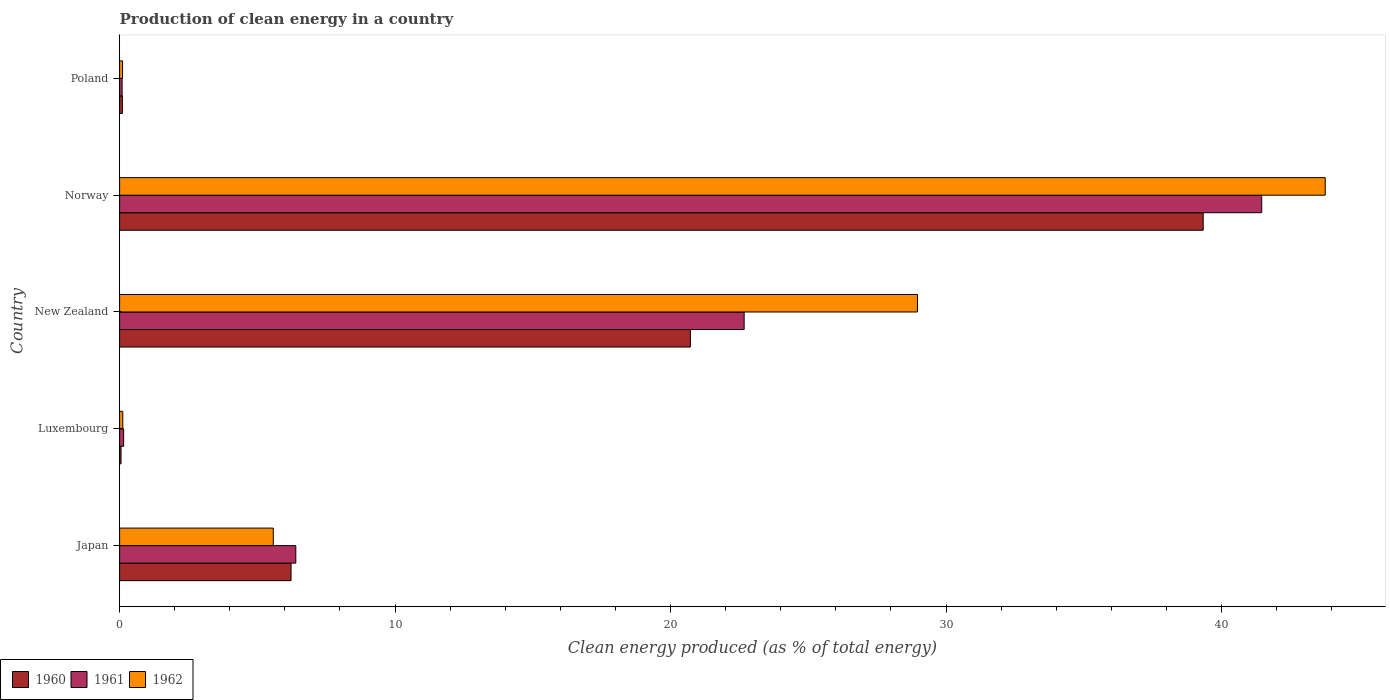How many groups of bars are there?
Provide a short and direct response. 5. How many bars are there on the 1st tick from the bottom?
Ensure brevity in your answer.  3. What is the label of the 5th group of bars from the top?
Your answer should be compact. Japan. In how many cases, is the number of bars for a given country not equal to the number of legend labels?
Ensure brevity in your answer.  0. What is the percentage of clean energy produced in 1962 in Luxembourg?
Offer a terse response. 0.12. Across all countries, what is the maximum percentage of clean energy produced in 1960?
Provide a short and direct response. 39.34. Across all countries, what is the minimum percentage of clean energy produced in 1962?
Your response must be concise. 0.11. In which country was the percentage of clean energy produced in 1962 minimum?
Provide a short and direct response. Poland. What is the total percentage of clean energy produced in 1962 in the graph?
Your response must be concise. 78.53. What is the difference between the percentage of clean energy produced in 1960 in Luxembourg and that in Norway?
Keep it short and to the point. -39.28. What is the difference between the percentage of clean energy produced in 1960 in Poland and the percentage of clean energy produced in 1961 in Luxembourg?
Your answer should be very brief. -0.05. What is the average percentage of clean energy produced in 1960 per country?
Your answer should be compact. 13.29. What is the difference between the percentage of clean energy produced in 1962 and percentage of clean energy produced in 1961 in Poland?
Provide a short and direct response. 0.02. What is the ratio of the percentage of clean energy produced in 1960 in Japan to that in New Zealand?
Offer a very short reply. 0.3. Is the percentage of clean energy produced in 1961 in Japan less than that in Poland?
Offer a terse response. No. What is the difference between the highest and the second highest percentage of clean energy produced in 1962?
Provide a short and direct response. 14.8. What is the difference between the highest and the lowest percentage of clean energy produced in 1961?
Keep it short and to the point. 41.37. In how many countries, is the percentage of clean energy produced in 1962 greater than the average percentage of clean energy produced in 1962 taken over all countries?
Provide a succinct answer. 2. What does the 3rd bar from the top in New Zealand represents?
Your response must be concise. 1960. What does the 2nd bar from the bottom in New Zealand represents?
Provide a succinct answer. 1961. What is the difference between two consecutive major ticks on the X-axis?
Keep it short and to the point. 10. Are the values on the major ticks of X-axis written in scientific E-notation?
Ensure brevity in your answer.  No. Does the graph contain any zero values?
Provide a succinct answer. No. How many legend labels are there?
Your answer should be compact. 3. What is the title of the graph?
Your answer should be very brief. Production of clean energy in a country. Does "1961" appear as one of the legend labels in the graph?
Make the answer very short. Yes. What is the label or title of the X-axis?
Your answer should be compact. Clean energy produced (as % of total energy). What is the label or title of the Y-axis?
Offer a very short reply. Country. What is the Clean energy produced (as % of total energy) in 1960 in Japan?
Offer a terse response. 6.22. What is the Clean energy produced (as % of total energy) of 1961 in Japan?
Make the answer very short. 6.4. What is the Clean energy produced (as % of total energy) of 1962 in Japan?
Provide a succinct answer. 5.58. What is the Clean energy produced (as % of total energy) of 1960 in Luxembourg?
Your answer should be compact. 0.05. What is the Clean energy produced (as % of total energy) in 1961 in Luxembourg?
Keep it short and to the point. 0.15. What is the Clean energy produced (as % of total energy) of 1962 in Luxembourg?
Make the answer very short. 0.12. What is the Clean energy produced (as % of total energy) of 1960 in New Zealand?
Your answer should be very brief. 20.72. What is the Clean energy produced (as % of total energy) of 1961 in New Zealand?
Provide a short and direct response. 22.67. What is the Clean energy produced (as % of total energy) of 1962 in New Zealand?
Provide a succinct answer. 28.96. What is the Clean energy produced (as % of total energy) in 1960 in Norway?
Keep it short and to the point. 39.34. What is the Clean energy produced (as % of total energy) of 1961 in Norway?
Ensure brevity in your answer.  41.46. What is the Clean energy produced (as % of total energy) in 1962 in Norway?
Your answer should be very brief. 43.77. What is the Clean energy produced (as % of total energy) of 1960 in Poland?
Provide a short and direct response. 0.1. What is the Clean energy produced (as % of total energy) of 1961 in Poland?
Your answer should be very brief. 0.09. What is the Clean energy produced (as % of total energy) of 1962 in Poland?
Offer a terse response. 0.11. Across all countries, what is the maximum Clean energy produced (as % of total energy) of 1960?
Provide a succinct answer. 39.34. Across all countries, what is the maximum Clean energy produced (as % of total energy) in 1961?
Keep it short and to the point. 41.46. Across all countries, what is the maximum Clean energy produced (as % of total energy) in 1962?
Keep it short and to the point. 43.77. Across all countries, what is the minimum Clean energy produced (as % of total energy) of 1960?
Your response must be concise. 0.05. Across all countries, what is the minimum Clean energy produced (as % of total energy) of 1961?
Give a very brief answer. 0.09. Across all countries, what is the minimum Clean energy produced (as % of total energy) of 1962?
Make the answer very short. 0.11. What is the total Clean energy produced (as % of total energy) of 1960 in the graph?
Keep it short and to the point. 66.43. What is the total Clean energy produced (as % of total energy) of 1961 in the graph?
Offer a terse response. 70.77. What is the total Clean energy produced (as % of total energy) in 1962 in the graph?
Keep it short and to the point. 78.53. What is the difference between the Clean energy produced (as % of total energy) of 1960 in Japan and that in Luxembourg?
Make the answer very short. 6.17. What is the difference between the Clean energy produced (as % of total energy) in 1961 in Japan and that in Luxembourg?
Give a very brief answer. 6.25. What is the difference between the Clean energy produced (as % of total energy) of 1962 in Japan and that in Luxembourg?
Keep it short and to the point. 5.46. What is the difference between the Clean energy produced (as % of total energy) in 1960 in Japan and that in New Zealand?
Provide a succinct answer. -14.5. What is the difference between the Clean energy produced (as % of total energy) of 1961 in Japan and that in New Zealand?
Your answer should be compact. -16.28. What is the difference between the Clean energy produced (as % of total energy) in 1962 in Japan and that in New Zealand?
Your answer should be compact. -23.38. What is the difference between the Clean energy produced (as % of total energy) in 1960 in Japan and that in Norway?
Your answer should be very brief. -33.11. What is the difference between the Clean energy produced (as % of total energy) of 1961 in Japan and that in Norway?
Keep it short and to the point. -35.06. What is the difference between the Clean energy produced (as % of total energy) of 1962 in Japan and that in Norway?
Offer a terse response. -38.19. What is the difference between the Clean energy produced (as % of total energy) in 1960 in Japan and that in Poland?
Your response must be concise. 6.12. What is the difference between the Clean energy produced (as % of total energy) of 1961 in Japan and that in Poland?
Your response must be concise. 6.31. What is the difference between the Clean energy produced (as % of total energy) in 1962 in Japan and that in Poland?
Give a very brief answer. 5.47. What is the difference between the Clean energy produced (as % of total energy) of 1960 in Luxembourg and that in New Zealand?
Give a very brief answer. -20.67. What is the difference between the Clean energy produced (as % of total energy) of 1961 in Luxembourg and that in New Zealand?
Provide a succinct answer. -22.53. What is the difference between the Clean energy produced (as % of total energy) of 1962 in Luxembourg and that in New Zealand?
Keep it short and to the point. -28.85. What is the difference between the Clean energy produced (as % of total energy) of 1960 in Luxembourg and that in Norway?
Give a very brief answer. -39.28. What is the difference between the Clean energy produced (as % of total energy) in 1961 in Luxembourg and that in Norway?
Your answer should be compact. -41.31. What is the difference between the Clean energy produced (as % of total energy) of 1962 in Luxembourg and that in Norway?
Offer a terse response. -43.65. What is the difference between the Clean energy produced (as % of total energy) of 1960 in Luxembourg and that in Poland?
Give a very brief answer. -0.05. What is the difference between the Clean energy produced (as % of total energy) in 1961 in Luxembourg and that in Poland?
Provide a succinct answer. 0.06. What is the difference between the Clean energy produced (as % of total energy) in 1962 in Luxembourg and that in Poland?
Your answer should be compact. 0.01. What is the difference between the Clean energy produced (as % of total energy) of 1960 in New Zealand and that in Norway?
Provide a succinct answer. -18.62. What is the difference between the Clean energy produced (as % of total energy) of 1961 in New Zealand and that in Norway?
Offer a very short reply. -18.79. What is the difference between the Clean energy produced (as % of total energy) of 1962 in New Zealand and that in Norway?
Your answer should be compact. -14.8. What is the difference between the Clean energy produced (as % of total energy) in 1960 in New Zealand and that in Poland?
Give a very brief answer. 20.62. What is the difference between the Clean energy produced (as % of total energy) of 1961 in New Zealand and that in Poland?
Provide a short and direct response. 22.58. What is the difference between the Clean energy produced (as % of total energy) in 1962 in New Zealand and that in Poland?
Keep it short and to the point. 28.86. What is the difference between the Clean energy produced (as % of total energy) in 1960 in Norway and that in Poland?
Provide a short and direct response. 39.24. What is the difference between the Clean energy produced (as % of total energy) of 1961 in Norway and that in Poland?
Your response must be concise. 41.37. What is the difference between the Clean energy produced (as % of total energy) of 1962 in Norway and that in Poland?
Provide a short and direct response. 43.66. What is the difference between the Clean energy produced (as % of total energy) in 1960 in Japan and the Clean energy produced (as % of total energy) in 1961 in Luxembourg?
Your answer should be compact. 6.08. What is the difference between the Clean energy produced (as % of total energy) in 1960 in Japan and the Clean energy produced (as % of total energy) in 1962 in Luxembourg?
Your answer should be compact. 6.11. What is the difference between the Clean energy produced (as % of total energy) in 1961 in Japan and the Clean energy produced (as % of total energy) in 1962 in Luxembourg?
Provide a succinct answer. 6.28. What is the difference between the Clean energy produced (as % of total energy) in 1960 in Japan and the Clean energy produced (as % of total energy) in 1961 in New Zealand?
Make the answer very short. -16.45. What is the difference between the Clean energy produced (as % of total energy) in 1960 in Japan and the Clean energy produced (as % of total energy) in 1962 in New Zealand?
Offer a terse response. -22.74. What is the difference between the Clean energy produced (as % of total energy) of 1961 in Japan and the Clean energy produced (as % of total energy) of 1962 in New Zealand?
Ensure brevity in your answer.  -22.57. What is the difference between the Clean energy produced (as % of total energy) in 1960 in Japan and the Clean energy produced (as % of total energy) in 1961 in Norway?
Offer a terse response. -35.24. What is the difference between the Clean energy produced (as % of total energy) in 1960 in Japan and the Clean energy produced (as % of total energy) in 1962 in Norway?
Provide a succinct answer. -37.54. What is the difference between the Clean energy produced (as % of total energy) in 1961 in Japan and the Clean energy produced (as % of total energy) in 1962 in Norway?
Your answer should be compact. -37.37. What is the difference between the Clean energy produced (as % of total energy) in 1960 in Japan and the Clean energy produced (as % of total energy) in 1961 in Poland?
Offer a very short reply. 6.13. What is the difference between the Clean energy produced (as % of total energy) in 1960 in Japan and the Clean energy produced (as % of total energy) in 1962 in Poland?
Provide a succinct answer. 6.12. What is the difference between the Clean energy produced (as % of total energy) of 1961 in Japan and the Clean energy produced (as % of total energy) of 1962 in Poland?
Provide a succinct answer. 6.29. What is the difference between the Clean energy produced (as % of total energy) of 1960 in Luxembourg and the Clean energy produced (as % of total energy) of 1961 in New Zealand?
Offer a terse response. -22.62. What is the difference between the Clean energy produced (as % of total energy) in 1960 in Luxembourg and the Clean energy produced (as % of total energy) in 1962 in New Zealand?
Keep it short and to the point. -28.91. What is the difference between the Clean energy produced (as % of total energy) in 1961 in Luxembourg and the Clean energy produced (as % of total energy) in 1962 in New Zealand?
Make the answer very short. -28.82. What is the difference between the Clean energy produced (as % of total energy) in 1960 in Luxembourg and the Clean energy produced (as % of total energy) in 1961 in Norway?
Your answer should be compact. -41.41. What is the difference between the Clean energy produced (as % of total energy) in 1960 in Luxembourg and the Clean energy produced (as % of total energy) in 1962 in Norway?
Your answer should be compact. -43.71. What is the difference between the Clean energy produced (as % of total energy) of 1961 in Luxembourg and the Clean energy produced (as % of total energy) of 1962 in Norway?
Ensure brevity in your answer.  -43.62. What is the difference between the Clean energy produced (as % of total energy) of 1960 in Luxembourg and the Clean energy produced (as % of total energy) of 1961 in Poland?
Provide a short and direct response. -0.04. What is the difference between the Clean energy produced (as % of total energy) in 1960 in Luxembourg and the Clean energy produced (as % of total energy) in 1962 in Poland?
Offer a terse response. -0.06. What is the difference between the Clean energy produced (as % of total energy) of 1961 in Luxembourg and the Clean energy produced (as % of total energy) of 1962 in Poland?
Ensure brevity in your answer.  0.04. What is the difference between the Clean energy produced (as % of total energy) of 1960 in New Zealand and the Clean energy produced (as % of total energy) of 1961 in Norway?
Ensure brevity in your answer.  -20.74. What is the difference between the Clean energy produced (as % of total energy) of 1960 in New Zealand and the Clean energy produced (as % of total energy) of 1962 in Norway?
Provide a succinct answer. -23.05. What is the difference between the Clean energy produced (as % of total energy) of 1961 in New Zealand and the Clean energy produced (as % of total energy) of 1962 in Norway?
Offer a very short reply. -21.09. What is the difference between the Clean energy produced (as % of total energy) in 1960 in New Zealand and the Clean energy produced (as % of total energy) in 1961 in Poland?
Give a very brief answer. 20.63. What is the difference between the Clean energy produced (as % of total energy) of 1960 in New Zealand and the Clean energy produced (as % of total energy) of 1962 in Poland?
Offer a very short reply. 20.61. What is the difference between the Clean energy produced (as % of total energy) in 1961 in New Zealand and the Clean energy produced (as % of total energy) in 1962 in Poland?
Offer a terse response. 22.56. What is the difference between the Clean energy produced (as % of total energy) in 1960 in Norway and the Clean energy produced (as % of total energy) in 1961 in Poland?
Make the answer very short. 39.24. What is the difference between the Clean energy produced (as % of total energy) of 1960 in Norway and the Clean energy produced (as % of total energy) of 1962 in Poland?
Offer a very short reply. 39.23. What is the difference between the Clean energy produced (as % of total energy) in 1961 in Norway and the Clean energy produced (as % of total energy) in 1962 in Poland?
Your answer should be very brief. 41.35. What is the average Clean energy produced (as % of total energy) in 1960 per country?
Your answer should be very brief. 13.29. What is the average Clean energy produced (as % of total energy) of 1961 per country?
Your response must be concise. 14.15. What is the average Clean energy produced (as % of total energy) in 1962 per country?
Your answer should be compact. 15.71. What is the difference between the Clean energy produced (as % of total energy) in 1960 and Clean energy produced (as % of total energy) in 1961 in Japan?
Give a very brief answer. -0.17. What is the difference between the Clean energy produced (as % of total energy) of 1960 and Clean energy produced (as % of total energy) of 1962 in Japan?
Offer a terse response. 0.64. What is the difference between the Clean energy produced (as % of total energy) in 1961 and Clean energy produced (as % of total energy) in 1962 in Japan?
Offer a terse response. 0.82. What is the difference between the Clean energy produced (as % of total energy) in 1960 and Clean energy produced (as % of total energy) in 1961 in Luxembourg?
Your response must be concise. -0.09. What is the difference between the Clean energy produced (as % of total energy) in 1960 and Clean energy produced (as % of total energy) in 1962 in Luxembourg?
Offer a very short reply. -0.06. What is the difference between the Clean energy produced (as % of total energy) of 1961 and Clean energy produced (as % of total energy) of 1962 in Luxembourg?
Give a very brief answer. 0.03. What is the difference between the Clean energy produced (as % of total energy) of 1960 and Clean energy produced (as % of total energy) of 1961 in New Zealand?
Your response must be concise. -1.95. What is the difference between the Clean energy produced (as % of total energy) in 1960 and Clean energy produced (as % of total energy) in 1962 in New Zealand?
Your answer should be very brief. -8.24. What is the difference between the Clean energy produced (as % of total energy) in 1961 and Clean energy produced (as % of total energy) in 1962 in New Zealand?
Keep it short and to the point. -6.29. What is the difference between the Clean energy produced (as % of total energy) in 1960 and Clean energy produced (as % of total energy) in 1961 in Norway?
Provide a succinct answer. -2.12. What is the difference between the Clean energy produced (as % of total energy) of 1960 and Clean energy produced (as % of total energy) of 1962 in Norway?
Give a very brief answer. -4.43. What is the difference between the Clean energy produced (as % of total energy) of 1961 and Clean energy produced (as % of total energy) of 1962 in Norway?
Give a very brief answer. -2.31. What is the difference between the Clean energy produced (as % of total energy) of 1960 and Clean energy produced (as % of total energy) of 1961 in Poland?
Offer a very short reply. 0.01. What is the difference between the Clean energy produced (as % of total energy) in 1960 and Clean energy produced (as % of total energy) in 1962 in Poland?
Provide a succinct answer. -0.01. What is the difference between the Clean energy produced (as % of total energy) of 1961 and Clean energy produced (as % of total energy) of 1962 in Poland?
Keep it short and to the point. -0.02. What is the ratio of the Clean energy produced (as % of total energy) in 1960 in Japan to that in Luxembourg?
Give a very brief answer. 119.55. What is the ratio of the Clean energy produced (as % of total energy) of 1961 in Japan to that in Luxembourg?
Offer a terse response. 43.55. What is the ratio of the Clean energy produced (as % of total energy) in 1962 in Japan to that in Luxembourg?
Give a very brief answer. 48.16. What is the ratio of the Clean energy produced (as % of total energy) in 1960 in Japan to that in New Zealand?
Give a very brief answer. 0.3. What is the ratio of the Clean energy produced (as % of total energy) in 1961 in Japan to that in New Zealand?
Give a very brief answer. 0.28. What is the ratio of the Clean energy produced (as % of total energy) in 1962 in Japan to that in New Zealand?
Your response must be concise. 0.19. What is the ratio of the Clean energy produced (as % of total energy) in 1960 in Japan to that in Norway?
Keep it short and to the point. 0.16. What is the ratio of the Clean energy produced (as % of total energy) in 1961 in Japan to that in Norway?
Offer a terse response. 0.15. What is the ratio of the Clean energy produced (as % of total energy) of 1962 in Japan to that in Norway?
Provide a short and direct response. 0.13. What is the ratio of the Clean energy produced (as % of total energy) of 1960 in Japan to that in Poland?
Offer a terse response. 62.03. What is the ratio of the Clean energy produced (as % of total energy) of 1961 in Japan to that in Poland?
Make the answer very short. 69.89. What is the ratio of the Clean energy produced (as % of total energy) in 1962 in Japan to that in Poland?
Your response must be concise. 51.55. What is the ratio of the Clean energy produced (as % of total energy) in 1960 in Luxembourg to that in New Zealand?
Offer a terse response. 0. What is the ratio of the Clean energy produced (as % of total energy) in 1961 in Luxembourg to that in New Zealand?
Make the answer very short. 0.01. What is the ratio of the Clean energy produced (as % of total energy) of 1962 in Luxembourg to that in New Zealand?
Ensure brevity in your answer.  0. What is the ratio of the Clean energy produced (as % of total energy) of 1960 in Luxembourg to that in Norway?
Keep it short and to the point. 0. What is the ratio of the Clean energy produced (as % of total energy) of 1961 in Luxembourg to that in Norway?
Keep it short and to the point. 0. What is the ratio of the Clean energy produced (as % of total energy) of 1962 in Luxembourg to that in Norway?
Offer a very short reply. 0. What is the ratio of the Clean energy produced (as % of total energy) in 1960 in Luxembourg to that in Poland?
Offer a very short reply. 0.52. What is the ratio of the Clean energy produced (as % of total energy) in 1961 in Luxembourg to that in Poland?
Your answer should be compact. 1.6. What is the ratio of the Clean energy produced (as % of total energy) of 1962 in Luxembourg to that in Poland?
Provide a short and direct response. 1.07. What is the ratio of the Clean energy produced (as % of total energy) of 1960 in New Zealand to that in Norway?
Provide a short and direct response. 0.53. What is the ratio of the Clean energy produced (as % of total energy) of 1961 in New Zealand to that in Norway?
Provide a short and direct response. 0.55. What is the ratio of the Clean energy produced (as % of total energy) of 1962 in New Zealand to that in Norway?
Offer a terse response. 0.66. What is the ratio of the Clean energy produced (as % of total energy) in 1960 in New Zealand to that in Poland?
Offer a terse response. 206.53. What is the ratio of the Clean energy produced (as % of total energy) of 1961 in New Zealand to that in Poland?
Provide a short and direct response. 247.72. What is the ratio of the Clean energy produced (as % of total energy) in 1962 in New Zealand to that in Poland?
Keep it short and to the point. 267.62. What is the ratio of the Clean energy produced (as % of total energy) in 1960 in Norway to that in Poland?
Keep it short and to the point. 392.08. What is the ratio of the Clean energy produced (as % of total energy) in 1961 in Norway to that in Poland?
Offer a very short reply. 452.99. What is the ratio of the Clean energy produced (as % of total energy) of 1962 in Norway to that in Poland?
Your answer should be compact. 404.39. What is the difference between the highest and the second highest Clean energy produced (as % of total energy) of 1960?
Make the answer very short. 18.62. What is the difference between the highest and the second highest Clean energy produced (as % of total energy) of 1961?
Ensure brevity in your answer.  18.79. What is the difference between the highest and the second highest Clean energy produced (as % of total energy) of 1962?
Offer a terse response. 14.8. What is the difference between the highest and the lowest Clean energy produced (as % of total energy) in 1960?
Offer a terse response. 39.28. What is the difference between the highest and the lowest Clean energy produced (as % of total energy) of 1961?
Keep it short and to the point. 41.37. What is the difference between the highest and the lowest Clean energy produced (as % of total energy) in 1962?
Your answer should be compact. 43.66. 